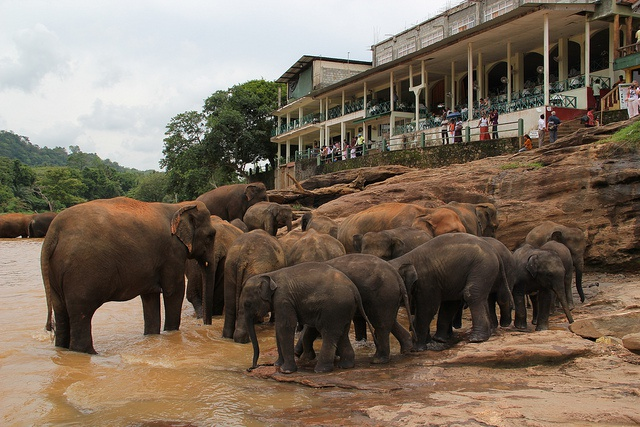Describe the objects in this image and their specific colors. I can see elephant in white, black, maroon, and gray tones, elephant in white, black, gray, and maroon tones, elephant in white, black, gray, and maroon tones, elephant in white, black, maroon, and gray tones, and elephant in white, black, gray, and maroon tones in this image. 